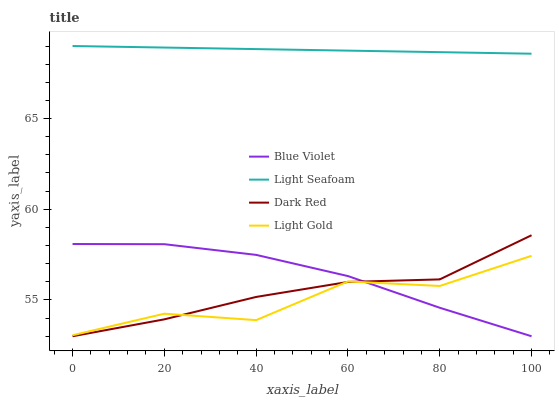Does Light Gold have the minimum area under the curve?
Answer yes or no. Yes. Does Light Seafoam have the minimum area under the curve?
Answer yes or no. No. Does Light Gold have the maximum area under the curve?
Answer yes or no. No. Is Light Gold the roughest?
Answer yes or no. Yes. Is Light Gold the smoothest?
Answer yes or no. No. Is Light Seafoam the roughest?
Answer yes or no. No. Does Light Gold have the lowest value?
Answer yes or no. No. Does Light Gold have the highest value?
Answer yes or no. No. Is Light Gold less than Light Seafoam?
Answer yes or no. Yes. Is Light Seafoam greater than Blue Violet?
Answer yes or no. Yes. Does Light Gold intersect Light Seafoam?
Answer yes or no. No. 